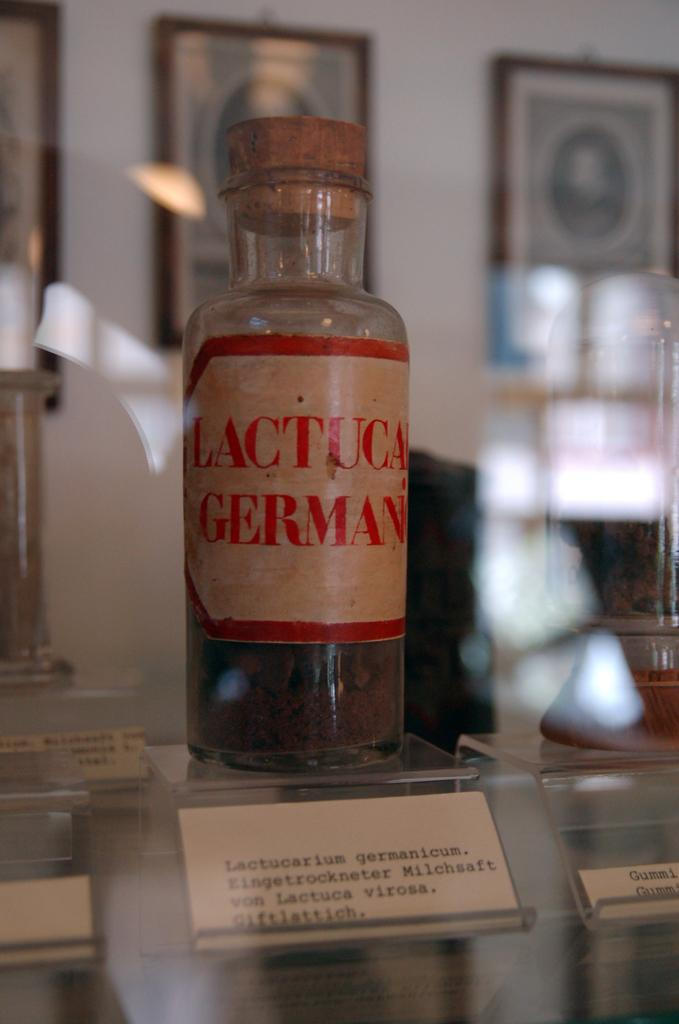Provide a one-sentence caption for the provided image. A bottle labelled Lactucarium Germanicum sits on display with some other things. 